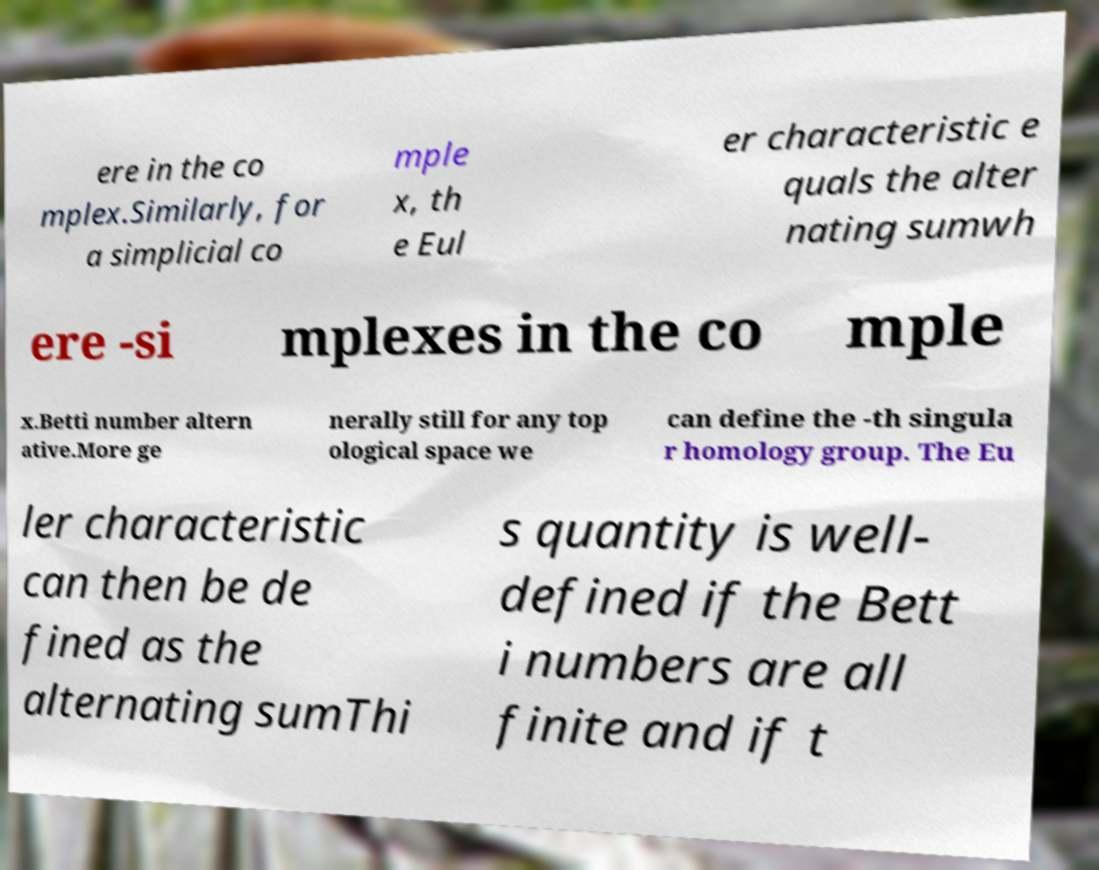Can you read and provide the text displayed in the image?This photo seems to have some interesting text. Can you extract and type it out for me? ere in the co mplex.Similarly, for a simplicial co mple x, th e Eul er characteristic e quals the alter nating sumwh ere -si mplexes in the co mple x.Betti number altern ative.More ge nerally still for any top ological space we can define the -th singula r homology group. The Eu ler characteristic can then be de fined as the alternating sumThi s quantity is well- defined if the Bett i numbers are all finite and if t 